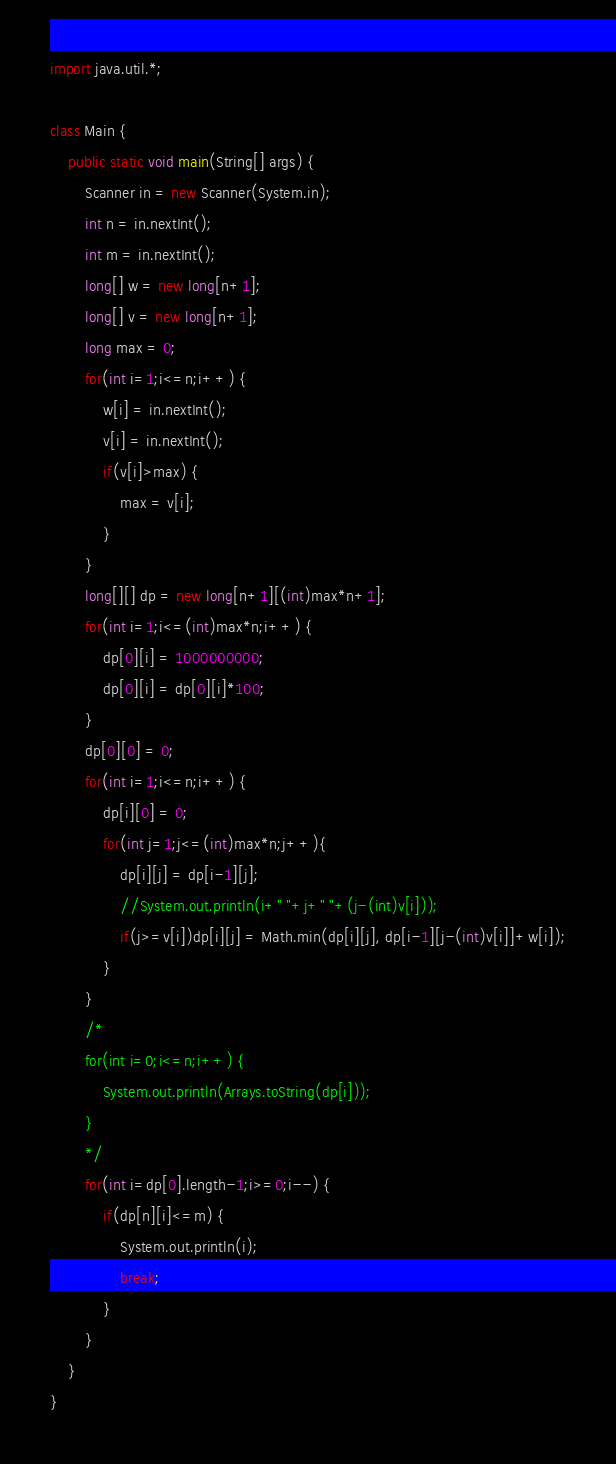Convert code to text. <code><loc_0><loc_0><loc_500><loc_500><_Java_>import java.util.*;

class Main {
	public static void main(String[] args) {
		Scanner in = new Scanner(System.in);
		int n = in.nextInt();
		int m = in.nextInt();
		long[] w = new long[n+1];
		long[] v = new long[n+1];
		long max = 0;
		for(int i=1;i<=n;i++) {
			w[i] = in.nextInt();
			v[i] = in.nextInt();
			if(v[i]>max) {
				max = v[i];
			}
		}
		long[][] dp = new long[n+1][(int)max*n+1];
		for(int i=1;i<=(int)max*n;i++) {
			dp[0][i] = 1000000000;
			dp[0][i] = dp[0][i]*100;
		}
		dp[0][0] = 0;
		for(int i=1;i<=n;i++) {
			dp[i][0] = 0;
			for(int j=1;j<=(int)max*n;j++){
				dp[i][j] = dp[i-1][j];
				//System.out.println(i+" "+j+" "+(j-(int)v[i]));
				if(j>=v[i])dp[i][j] = Math.min(dp[i][j], dp[i-1][j-(int)v[i]]+w[i]);
			}
		}
		/*
		for(int i=0;i<=n;i++) {
			System.out.println(Arrays.toString(dp[i]));
		}
		*/
		for(int i=dp[0].length-1;i>=0;i--) {
			if(dp[n][i]<=m) {
				System.out.println(i);
				break;
			}
		}
	}
}</code> 